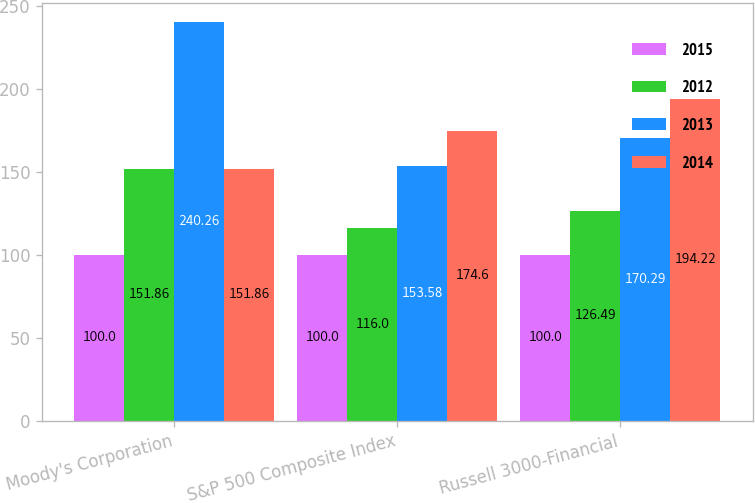Convert chart. <chart><loc_0><loc_0><loc_500><loc_500><stacked_bar_chart><ecel><fcel>Moody's Corporation<fcel>S&P 500 Composite Index<fcel>Russell 3000-Financial<nl><fcel>2015<fcel>100<fcel>100<fcel>100<nl><fcel>2012<fcel>151.86<fcel>116<fcel>126.49<nl><fcel>2013<fcel>240.26<fcel>153.58<fcel>170.29<nl><fcel>2014<fcel>151.86<fcel>174.6<fcel>194.22<nl></chart> 